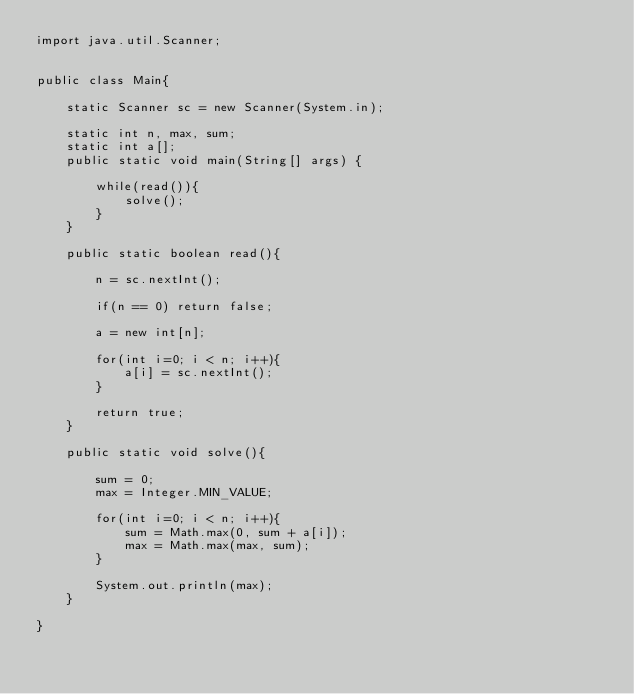<code> <loc_0><loc_0><loc_500><loc_500><_Java_>import java.util.Scanner;


public class Main{

	static Scanner sc = new Scanner(System.in);
	
	static int n, max, sum;
	static int a[];
	public static void main(String[] args) {
		
		while(read()){
			solve();
		}
	}
	
	public static boolean read(){
		
		n = sc.nextInt();
		
		if(n == 0) return false;
		
		a = new int[n];
		
		for(int i=0; i < n; i++){
			a[i] = sc.nextInt();
		}
		
		return true;
	}
	
	public static void solve(){

		sum = 0;
		max = Integer.MIN_VALUE;
		
		for(int i=0; i < n; i++){
			sum = Math.max(0, sum + a[i]);
			max = Math.max(max, sum);
		}
		
		System.out.println(max);
	}

}</code> 